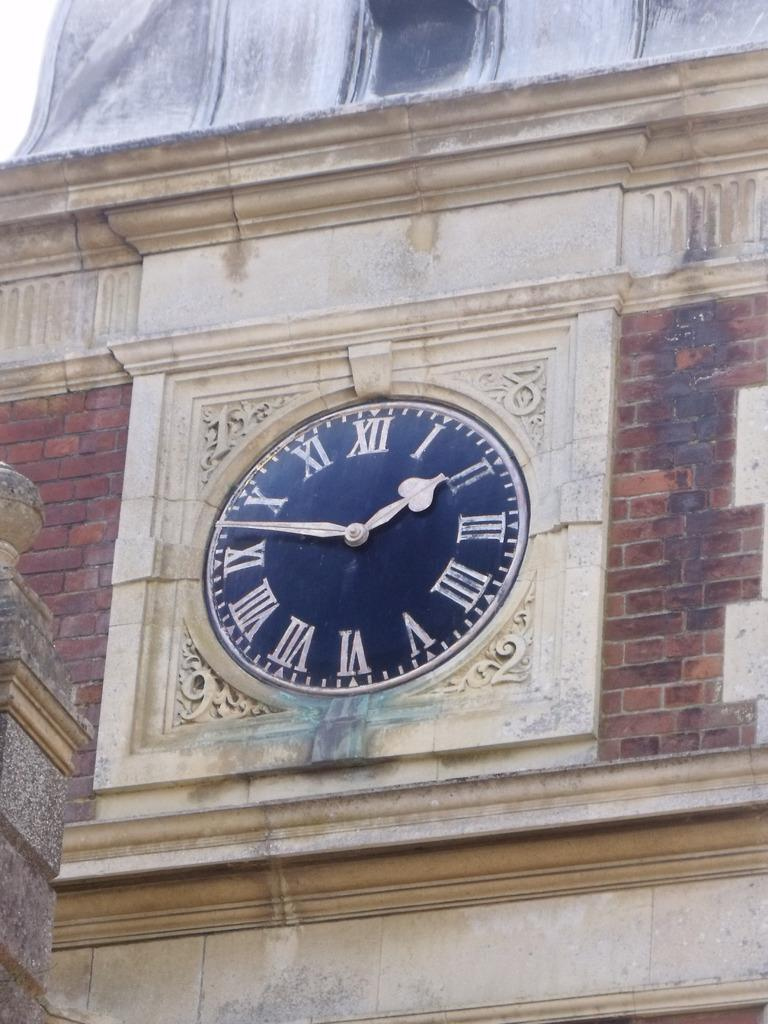What can you identify any time-telling device in the image? Yes, there is a clock on the wall in the image. What is the color of the bricks in the image? The bricks are red in color. What type of coat is the clock wearing in the image? There is no coat present in the image, as the clock is a wall-mounted device. Can you see the nose of the bricks in the image? Bricks do not have noses, as they are inanimate objects. 